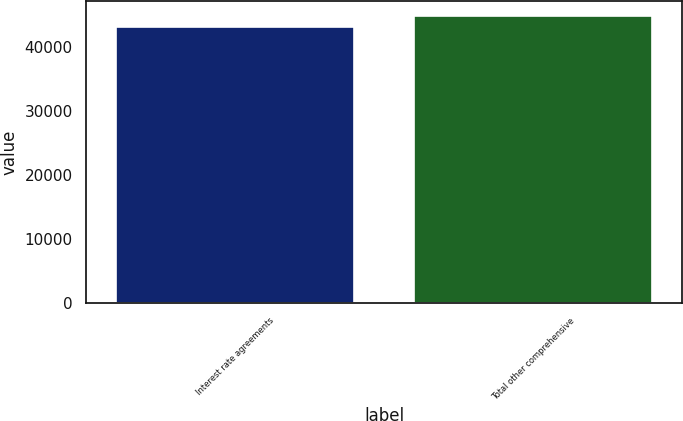Convert chart to OTSL. <chart><loc_0><loc_0><loc_500><loc_500><bar_chart><fcel>Interest rate agreements<fcel>Total other comprehensive<nl><fcel>43184<fcel>44936<nl></chart> 